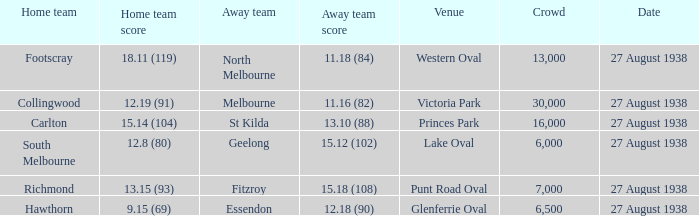How many people witnessed their home team score 13.15 (93)? 7000.0. 